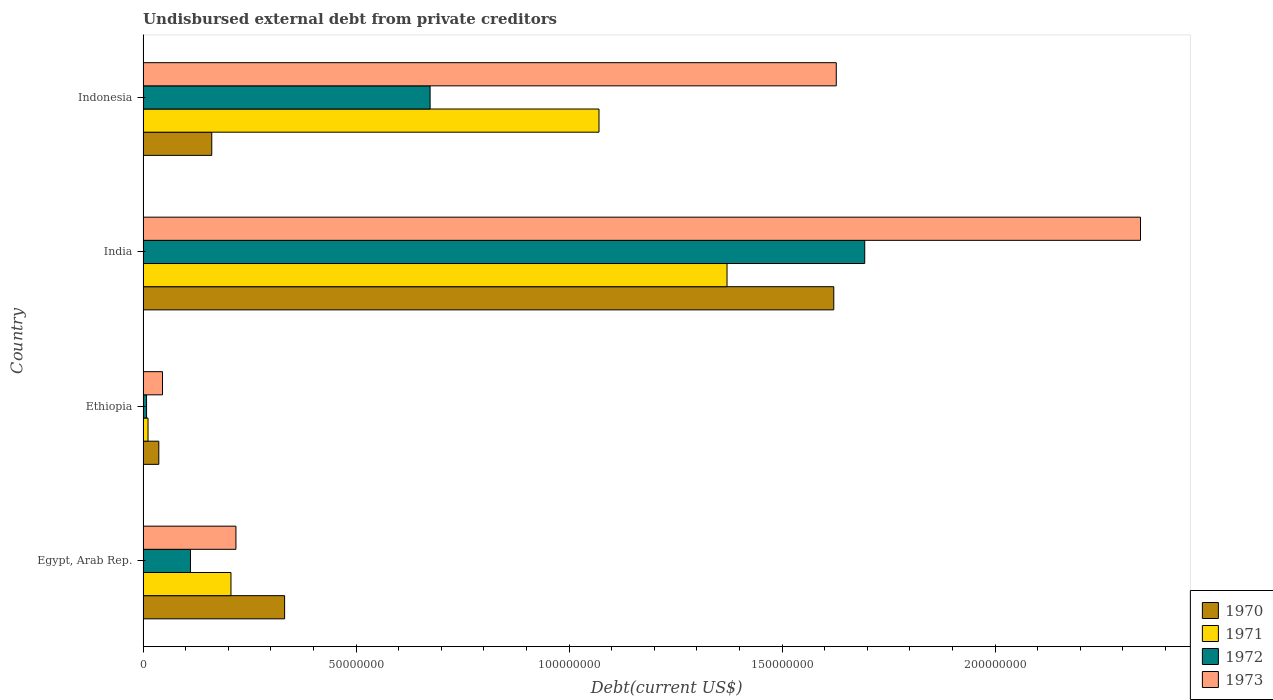How many bars are there on the 2nd tick from the top?
Offer a terse response. 4. How many bars are there on the 3rd tick from the bottom?
Ensure brevity in your answer.  4. What is the label of the 4th group of bars from the top?
Offer a terse response. Egypt, Arab Rep. In how many cases, is the number of bars for a given country not equal to the number of legend labels?
Your response must be concise. 0. What is the total debt in 1973 in India?
Your response must be concise. 2.34e+08. Across all countries, what is the maximum total debt in 1972?
Offer a very short reply. 1.69e+08. Across all countries, what is the minimum total debt in 1972?
Your answer should be compact. 8.20e+05. In which country was the total debt in 1973 minimum?
Provide a succinct answer. Ethiopia. What is the total total debt in 1973 in the graph?
Provide a succinct answer. 4.23e+08. What is the difference between the total debt in 1970 in India and that in Indonesia?
Provide a short and direct response. 1.46e+08. What is the difference between the total debt in 1973 in India and the total debt in 1970 in Indonesia?
Offer a terse response. 2.18e+08. What is the average total debt in 1970 per country?
Ensure brevity in your answer.  5.38e+07. What is the difference between the total debt in 1973 and total debt in 1972 in India?
Offer a very short reply. 6.47e+07. What is the ratio of the total debt in 1973 in Egypt, Arab Rep. to that in Indonesia?
Your response must be concise. 0.13. Is the total debt in 1971 in Egypt, Arab Rep. less than that in Ethiopia?
Your response must be concise. No. What is the difference between the highest and the second highest total debt in 1973?
Offer a terse response. 7.14e+07. What is the difference between the highest and the lowest total debt in 1971?
Your answer should be very brief. 1.36e+08. Is the sum of the total debt in 1971 in Ethiopia and India greater than the maximum total debt in 1972 across all countries?
Provide a short and direct response. No. Is it the case that in every country, the sum of the total debt in 1973 and total debt in 1972 is greater than the sum of total debt in 1971 and total debt in 1970?
Give a very brief answer. No. Is it the case that in every country, the sum of the total debt in 1971 and total debt in 1973 is greater than the total debt in 1970?
Give a very brief answer. Yes. How many bars are there?
Your answer should be very brief. 16. What is the difference between two consecutive major ticks on the X-axis?
Your response must be concise. 5.00e+07. Does the graph contain any zero values?
Your answer should be very brief. No. Does the graph contain grids?
Keep it short and to the point. No. How are the legend labels stacked?
Provide a succinct answer. Vertical. What is the title of the graph?
Your answer should be very brief. Undisbursed external debt from private creditors. What is the label or title of the X-axis?
Provide a succinct answer. Debt(current US$). What is the label or title of the Y-axis?
Your response must be concise. Country. What is the Debt(current US$) of 1970 in Egypt, Arab Rep.?
Offer a terse response. 3.32e+07. What is the Debt(current US$) in 1971 in Egypt, Arab Rep.?
Your response must be concise. 2.06e+07. What is the Debt(current US$) in 1972 in Egypt, Arab Rep.?
Your answer should be compact. 1.11e+07. What is the Debt(current US$) in 1973 in Egypt, Arab Rep.?
Make the answer very short. 2.18e+07. What is the Debt(current US$) in 1970 in Ethiopia?
Make the answer very short. 3.70e+06. What is the Debt(current US$) in 1971 in Ethiopia?
Your answer should be compact. 1.16e+06. What is the Debt(current US$) in 1972 in Ethiopia?
Your response must be concise. 8.20e+05. What is the Debt(current US$) of 1973 in Ethiopia?
Keep it short and to the point. 4.57e+06. What is the Debt(current US$) in 1970 in India?
Provide a succinct answer. 1.62e+08. What is the Debt(current US$) of 1971 in India?
Provide a short and direct response. 1.37e+08. What is the Debt(current US$) in 1972 in India?
Offer a terse response. 1.69e+08. What is the Debt(current US$) in 1973 in India?
Your answer should be very brief. 2.34e+08. What is the Debt(current US$) of 1970 in Indonesia?
Your answer should be very brief. 1.61e+07. What is the Debt(current US$) in 1971 in Indonesia?
Offer a very short reply. 1.07e+08. What is the Debt(current US$) in 1972 in Indonesia?
Your answer should be compact. 6.74e+07. What is the Debt(current US$) of 1973 in Indonesia?
Offer a very short reply. 1.63e+08. Across all countries, what is the maximum Debt(current US$) in 1970?
Your response must be concise. 1.62e+08. Across all countries, what is the maximum Debt(current US$) of 1971?
Provide a succinct answer. 1.37e+08. Across all countries, what is the maximum Debt(current US$) in 1972?
Make the answer very short. 1.69e+08. Across all countries, what is the maximum Debt(current US$) of 1973?
Provide a succinct answer. 2.34e+08. Across all countries, what is the minimum Debt(current US$) of 1970?
Provide a short and direct response. 3.70e+06. Across all countries, what is the minimum Debt(current US$) in 1971?
Ensure brevity in your answer.  1.16e+06. Across all countries, what is the minimum Debt(current US$) in 1972?
Keep it short and to the point. 8.20e+05. Across all countries, what is the minimum Debt(current US$) in 1973?
Your answer should be compact. 4.57e+06. What is the total Debt(current US$) in 1970 in the graph?
Provide a succinct answer. 2.15e+08. What is the total Debt(current US$) in 1971 in the graph?
Your answer should be compact. 2.66e+08. What is the total Debt(current US$) of 1972 in the graph?
Provide a succinct answer. 2.49e+08. What is the total Debt(current US$) in 1973 in the graph?
Your answer should be very brief. 4.23e+08. What is the difference between the Debt(current US$) in 1970 in Egypt, Arab Rep. and that in Ethiopia?
Provide a short and direct response. 2.95e+07. What is the difference between the Debt(current US$) of 1971 in Egypt, Arab Rep. and that in Ethiopia?
Your answer should be compact. 1.95e+07. What is the difference between the Debt(current US$) of 1972 in Egypt, Arab Rep. and that in Ethiopia?
Your answer should be very brief. 1.03e+07. What is the difference between the Debt(current US$) in 1973 in Egypt, Arab Rep. and that in Ethiopia?
Offer a terse response. 1.72e+07. What is the difference between the Debt(current US$) of 1970 in Egypt, Arab Rep. and that in India?
Your answer should be compact. -1.29e+08. What is the difference between the Debt(current US$) in 1971 in Egypt, Arab Rep. and that in India?
Your answer should be very brief. -1.16e+08. What is the difference between the Debt(current US$) in 1972 in Egypt, Arab Rep. and that in India?
Your answer should be very brief. -1.58e+08. What is the difference between the Debt(current US$) of 1973 in Egypt, Arab Rep. and that in India?
Give a very brief answer. -2.12e+08. What is the difference between the Debt(current US$) of 1970 in Egypt, Arab Rep. and that in Indonesia?
Ensure brevity in your answer.  1.71e+07. What is the difference between the Debt(current US$) in 1971 in Egypt, Arab Rep. and that in Indonesia?
Keep it short and to the point. -8.64e+07. What is the difference between the Debt(current US$) of 1972 in Egypt, Arab Rep. and that in Indonesia?
Your response must be concise. -5.62e+07. What is the difference between the Debt(current US$) of 1973 in Egypt, Arab Rep. and that in Indonesia?
Ensure brevity in your answer.  -1.41e+08. What is the difference between the Debt(current US$) in 1970 in Ethiopia and that in India?
Give a very brief answer. -1.58e+08. What is the difference between the Debt(current US$) in 1971 in Ethiopia and that in India?
Provide a short and direct response. -1.36e+08. What is the difference between the Debt(current US$) of 1972 in Ethiopia and that in India?
Ensure brevity in your answer.  -1.69e+08. What is the difference between the Debt(current US$) in 1973 in Ethiopia and that in India?
Your response must be concise. -2.30e+08. What is the difference between the Debt(current US$) of 1970 in Ethiopia and that in Indonesia?
Provide a short and direct response. -1.24e+07. What is the difference between the Debt(current US$) in 1971 in Ethiopia and that in Indonesia?
Keep it short and to the point. -1.06e+08. What is the difference between the Debt(current US$) of 1972 in Ethiopia and that in Indonesia?
Your answer should be very brief. -6.66e+07. What is the difference between the Debt(current US$) of 1973 in Ethiopia and that in Indonesia?
Your response must be concise. -1.58e+08. What is the difference between the Debt(current US$) of 1970 in India and that in Indonesia?
Provide a short and direct response. 1.46e+08. What is the difference between the Debt(current US$) of 1971 in India and that in Indonesia?
Your answer should be compact. 3.00e+07. What is the difference between the Debt(current US$) of 1972 in India and that in Indonesia?
Your answer should be very brief. 1.02e+08. What is the difference between the Debt(current US$) in 1973 in India and that in Indonesia?
Offer a very short reply. 7.14e+07. What is the difference between the Debt(current US$) in 1970 in Egypt, Arab Rep. and the Debt(current US$) in 1971 in Ethiopia?
Your answer should be compact. 3.21e+07. What is the difference between the Debt(current US$) in 1970 in Egypt, Arab Rep. and the Debt(current US$) in 1972 in Ethiopia?
Offer a terse response. 3.24e+07. What is the difference between the Debt(current US$) of 1970 in Egypt, Arab Rep. and the Debt(current US$) of 1973 in Ethiopia?
Make the answer very short. 2.87e+07. What is the difference between the Debt(current US$) in 1971 in Egypt, Arab Rep. and the Debt(current US$) in 1972 in Ethiopia?
Your response must be concise. 1.98e+07. What is the difference between the Debt(current US$) in 1971 in Egypt, Arab Rep. and the Debt(current US$) in 1973 in Ethiopia?
Keep it short and to the point. 1.61e+07. What is the difference between the Debt(current US$) of 1972 in Egypt, Arab Rep. and the Debt(current US$) of 1973 in Ethiopia?
Offer a very short reply. 6.56e+06. What is the difference between the Debt(current US$) of 1970 in Egypt, Arab Rep. and the Debt(current US$) of 1971 in India?
Your response must be concise. -1.04e+08. What is the difference between the Debt(current US$) of 1970 in Egypt, Arab Rep. and the Debt(current US$) of 1972 in India?
Provide a succinct answer. -1.36e+08. What is the difference between the Debt(current US$) of 1970 in Egypt, Arab Rep. and the Debt(current US$) of 1973 in India?
Make the answer very short. -2.01e+08. What is the difference between the Debt(current US$) of 1971 in Egypt, Arab Rep. and the Debt(current US$) of 1972 in India?
Your response must be concise. -1.49e+08. What is the difference between the Debt(current US$) in 1971 in Egypt, Arab Rep. and the Debt(current US$) in 1973 in India?
Keep it short and to the point. -2.13e+08. What is the difference between the Debt(current US$) in 1972 in Egypt, Arab Rep. and the Debt(current US$) in 1973 in India?
Make the answer very short. -2.23e+08. What is the difference between the Debt(current US$) in 1970 in Egypt, Arab Rep. and the Debt(current US$) in 1971 in Indonesia?
Your answer should be very brief. -7.38e+07. What is the difference between the Debt(current US$) in 1970 in Egypt, Arab Rep. and the Debt(current US$) in 1972 in Indonesia?
Give a very brief answer. -3.42e+07. What is the difference between the Debt(current US$) of 1970 in Egypt, Arab Rep. and the Debt(current US$) of 1973 in Indonesia?
Keep it short and to the point. -1.29e+08. What is the difference between the Debt(current US$) in 1971 in Egypt, Arab Rep. and the Debt(current US$) in 1972 in Indonesia?
Provide a succinct answer. -4.67e+07. What is the difference between the Debt(current US$) of 1971 in Egypt, Arab Rep. and the Debt(current US$) of 1973 in Indonesia?
Your response must be concise. -1.42e+08. What is the difference between the Debt(current US$) of 1972 in Egypt, Arab Rep. and the Debt(current US$) of 1973 in Indonesia?
Provide a succinct answer. -1.52e+08. What is the difference between the Debt(current US$) of 1970 in Ethiopia and the Debt(current US$) of 1971 in India?
Provide a succinct answer. -1.33e+08. What is the difference between the Debt(current US$) in 1970 in Ethiopia and the Debt(current US$) in 1972 in India?
Provide a short and direct response. -1.66e+08. What is the difference between the Debt(current US$) of 1970 in Ethiopia and the Debt(current US$) of 1973 in India?
Your answer should be compact. -2.30e+08. What is the difference between the Debt(current US$) in 1971 in Ethiopia and the Debt(current US$) in 1972 in India?
Offer a very short reply. -1.68e+08. What is the difference between the Debt(current US$) in 1971 in Ethiopia and the Debt(current US$) in 1973 in India?
Ensure brevity in your answer.  -2.33e+08. What is the difference between the Debt(current US$) of 1972 in Ethiopia and the Debt(current US$) of 1973 in India?
Provide a short and direct response. -2.33e+08. What is the difference between the Debt(current US$) of 1970 in Ethiopia and the Debt(current US$) of 1971 in Indonesia?
Make the answer very short. -1.03e+08. What is the difference between the Debt(current US$) of 1970 in Ethiopia and the Debt(current US$) of 1972 in Indonesia?
Your answer should be compact. -6.37e+07. What is the difference between the Debt(current US$) of 1970 in Ethiopia and the Debt(current US$) of 1973 in Indonesia?
Provide a short and direct response. -1.59e+08. What is the difference between the Debt(current US$) in 1971 in Ethiopia and the Debt(current US$) in 1972 in Indonesia?
Ensure brevity in your answer.  -6.62e+07. What is the difference between the Debt(current US$) in 1971 in Ethiopia and the Debt(current US$) in 1973 in Indonesia?
Your answer should be compact. -1.62e+08. What is the difference between the Debt(current US$) of 1972 in Ethiopia and the Debt(current US$) of 1973 in Indonesia?
Provide a short and direct response. -1.62e+08. What is the difference between the Debt(current US$) of 1970 in India and the Debt(current US$) of 1971 in Indonesia?
Your answer should be compact. 5.51e+07. What is the difference between the Debt(current US$) of 1970 in India and the Debt(current US$) of 1972 in Indonesia?
Your answer should be compact. 9.47e+07. What is the difference between the Debt(current US$) in 1970 in India and the Debt(current US$) in 1973 in Indonesia?
Provide a short and direct response. -5.84e+05. What is the difference between the Debt(current US$) in 1971 in India and the Debt(current US$) in 1972 in Indonesia?
Offer a very short reply. 6.97e+07. What is the difference between the Debt(current US$) of 1971 in India and the Debt(current US$) of 1973 in Indonesia?
Provide a short and direct response. -2.56e+07. What is the difference between the Debt(current US$) in 1972 in India and the Debt(current US$) in 1973 in Indonesia?
Ensure brevity in your answer.  6.68e+06. What is the average Debt(current US$) in 1970 per country?
Give a very brief answer. 5.38e+07. What is the average Debt(current US$) in 1971 per country?
Your answer should be compact. 6.65e+07. What is the average Debt(current US$) in 1972 per country?
Give a very brief answer. 6.22e+07. What is the average Debt(current US$) in 1973 per country?
Your answer should be very brief. 1.06e+08. What is the difference between the Debt(current US$) in 1970 and Debt(current US$) in 1971 in Egypt, Arab Rep.?
Ensure brevity in your answer.  1.26e+07. What is the difference between the Debt(current US$) of 1970 and Debt(current US$) of 1972 in Egypt, Arab Rep.?
Make the answer very short. 2.21e+07. What is the difference between the Debt(current US$) of 1970 and Debt(current US$) of 1973 in Egypt, Arab Rep.?
Your response must be concise. 1.14e+07. What is the difference between the Debt(current US$) in 1971 and Debt(current US$) in 1972 in Egypt, Arab Rep.?
Provide a succinct answer. 9.50e+06. What is the difference between the Debt(current US$) of 1971 and Debt(current US$) of 1973 in Egypt, Arab Rep.?
Give a very brief answer. -1.17e+06. What is the difference between the Debt(current US$) of 1972 and Debt(current US$) of 1973 in Egypt, Arab Rep.?
Provide a succinct answer. -1.07e+07. What is the difference between the Debt(current US$) of 1970 and Debt(current US$) of 1971 in Ethiopia?
Ensure brevity in your answer.  2.53e+06. What is the difference between the Debt(current US$) in 1970 and Debt(current US$) in 1972 in Ethiopia?
Offer a very short reply. 2.88e+06. What is the difference between the Debt(current US$) in 1970 and Debt(current US$) in 1973 in Ethiopia?
Ensure brevity in your answer.  -8.70e+05. What is the difference between the Debt(current US$) of 1971 and Debt(current US$) of 1972 in Ethiopia?
Your answer should be compact. 3.45e+05. What is the difference between the Debt(current US$) in 1971 and Debt(current US$) in 1973 in Ethiopia?
Give a very brief answer. -3.40e+06. What is the difference between the Debt(current US$) of 1972 and Debt(current US$) of 1973 in Ethiopia?
Your answer should be compact. -3.75e+06. What is the difference between the Debt(current US$) of 1970 and Debt(current US$) of 1971 in India?
Your response must be concise. 2.51e+07. What is the difference between the Debt(current US$) in 1970 and Debt(current US$) in 1972 in India?
Offer a terse response. -7.26e+06. What is the difference between the Debt(current US$) in 1970 and Debt(current US$) in 1973 in India?
Give a very brief answer. -7.20e+07. What is the difference between the Debt(current US$) of 1971 and Debt(current US$) of 1972 in India?
Your answer should be very brief. -3.23e+07. What is the difference between the Debt(current US$) of 1971 and Debt(current US$) of 1973 in India?
Offer a very short reply. -9.70e+07. What is the difference between the Debt(current US$) of 1972 and Debt(current US$) of 1973 in India?
Offer a terse response. -6.47e+07. What is the difference between the Debt(current US$) in 1970 and Debt(current US$) in 1971 in Indonesia?
Your response must be concise. -9.09e+07. What is the difference between the Debt(current US$) in 1970 and Debt(current US$) in 1972 in Indonesia?
Your response must be concise. -5.12e+07. What is the difference between the Debt(current US$) of 1970 and Debt(current US$) of 1973 in Indonesia?
Your answer should be compact. -1.47e+08. What is the difference between the Debt(current US$) in 1971 and Debt(current US$) in 1972 in Indonesia?
Offer a terse response. 3.96e+07. What is the difference between the Debt(current US$) in 1971 and Debt(current US$) in 1973 in Indonesia?
Provide a short and direct response. -5.57e+07. What is the difference between the Debt(current US$) in 1972 and Debt(current US$) in 1973 in Indonesia?
Keep it short and to the point. -9.53e+07. What is the ratio of the Debt(current US$) in 1970 in Egypt, Arab Rep. to that in Ethiopia?
Offer a very short reply. 8.99. What is the ratio of the Debt(current US$) of 1971 in Egypt, Arab Rep. to that in Ethiopia?
Give a very brief answer. 17.71. What is the ratio of the Debt(current US$) in 1972 in Egypt, Arab Rep. to that in Ethiopia?
Make the answer very short. 13.57. What is the ratio of the Debt(current US$) in 1973 in Egypt, Arab Rep. to that in Ethiopia?
Keep it short and to the point. 4.77. What is the ratio of the Debt(current US$) in 1970 in Egypt, Arab Rep. to that in India?
Offer a very short reply. 0.2. What is the ratio of the Debt(current US$) in 1971 in Egypt, Arab Rep. to that in India?
Offer a very short reply. 0.15. What is the ratio of the Debt(current US$) of 1972 in Egypt, Arab Rep. to that in India?
Offer a terse response. 0.07. What is the ratio of the Debt(current US$) of 1973 in Egypt, Arab Rep. to that in India?
Provide a short and direct response. 0.09. What is the ratio of the Debt(current US$) in 1970 in Egypt, Arab Rep. to that in Indonesia?
Keep it short and to the point. 2.06. What is the ratio of the Debt(current US$) of 1971 in Egypt, Arab Rep. to that in Indonesia?
Provide a short and direct response. 0.19. What is the ratio of the Debt(current US$) of 1972 in Egypt, Arab Rep. to that in Indonesia?
Offer a very short reply. 0.17. What is the ratio of the Debt(current US$) of 1973 in Egypt, Arab Rep. to that in Indonesia?
Your answer should be compact. 0.13. What is the ratio of the Debt(current US$) of 1970 in Ethiopia to that in India?
Offer a very short reply. 0.02. What is the ratio of the Debt(current US$) in 1971 in Ethiopia to that in India?
Make the answer very short. 0.01. What is the ratio of the Debt(current US$) in 1972 in Ethiopia to that in India?
Give a very brief answer. 0. What is the ratio of the Debt(current US$) in 1973 in Ethiopia to that in India?
Offer a very short reply. 0.02. What is the ratio of the Debt(current US$) of 1970 in Ethiopia to that in Indonesia?
Provide a short and direct response. 0.23. What is the ratio of the Debt(current US$) of 1971 in Ethiopia to that in Indonesia?
Provide a short and direct response. 0.01. What is the ratio of the Debt(current US$) of 1972 in Ethiopia to that in Indonesia?
Offer a very short reply. 0.01. What is the ratio of the Debt(current US$) in 1973 in Ethiopia to that in Indonesia?
Make the answer very short. 0.03. What is the ratio of the Debt(current US$) of 1970 in India to that in Indonesia?
Your answer should be compact. 10.05. What is the ratio of the Debt(current US$) of 1971 in India to that in Indonesia?
Make the answer very short. 1.28. What is the ratio of the Debt(current US$) of 1972 in India to that in Indonesia?
Make the answer very short. 2.51. What is the ratio of the Debt(current US$) of 1973 in India to that in Indonesia?
Keep it short and to the point. 1.44. What is the difference between the highest and the second highest Debt(current US$) in 1970?
Your answer should be compact. 1.29e+08. What is the difference between the highest and the second highest Debt(current US$) of 1971?
Provide a short and direct response. 3.00e+07. What is the difference between the highest and the second highest Debt(current US$) in 1972?
Offer a terse response. 1.02e+08. What is the difference between the highest and the second highest Debt(current US$) in 1973?
Give a very brief answer. 7.14e+07. What is the difference between the highest and the lowest Debt(current US$) in 1970?
Offer a terse response. 1.58e+08. What is the difference between the highest and the lowest Debt(current US$) in 1971?
Offer a terse response. 1.36e+08. What is the difference between the highest and the lowest Debt(current US$) of 1972?
Your response must be concise. 1.69e+08. What is the difference between the highest and the lowest Debt(current US$) of 1973?
Your answer should be compact. 2.30e+08. 